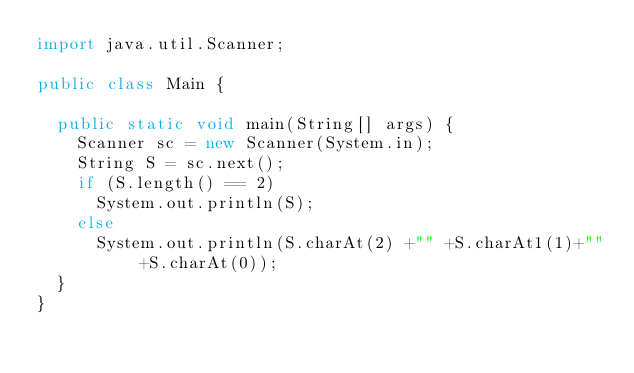Convert code to text. <code><loc_0><loc_0><loc_500><loc_500><_Java_>import java.util.Scanner;

public class Main {

	public static void main(String[] args) {
		Scanner sc = new Scanner(System.in);
		String S = sc.next();
		if (S.length() == 2)
			System.out.println(S);
		else
			System.out.println(S.charAt(2) +"" +S.charAt1(1)+"" +S.charAt(0));
	}
}	
</code> 